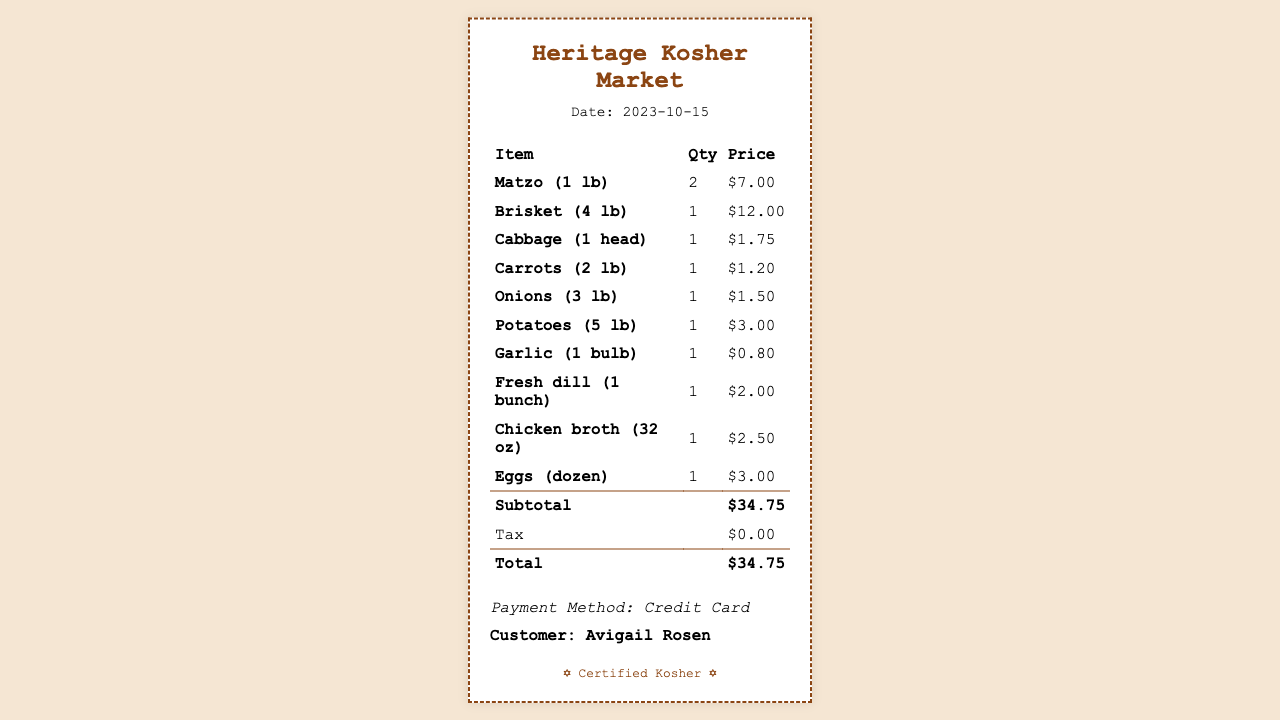what is the date of the receipt? The date of the receipt is listed prominently in the document.
Answer: 2023-10-15 who is the customer? The customer’s name is provided at the bottom of the receipt.
Answer: Avigail Rosen how many pounds of brisket were purchased? The quantity of brisket is specified in the item listing.
Answer: 4 lb what is the price of one lb of matzo? The price for matzo is given in the item section of the receipt.
Answer: $7.00 what is the subtotal amount? The subtotal is clearly indicated in the totals section of the receipt.
Answer: $34.75 what item has the lowest price? By examining the prices listed, the item with the lowest cost can be identified.
Answer: Garlic how many heads of cabbage were bought? The quantity of cabbage is mentioned in the item entry for cabbage.
Answer: 1 what payment method was used? The payment method is specified toward the end of the receipt.
Answer: Credit Card 